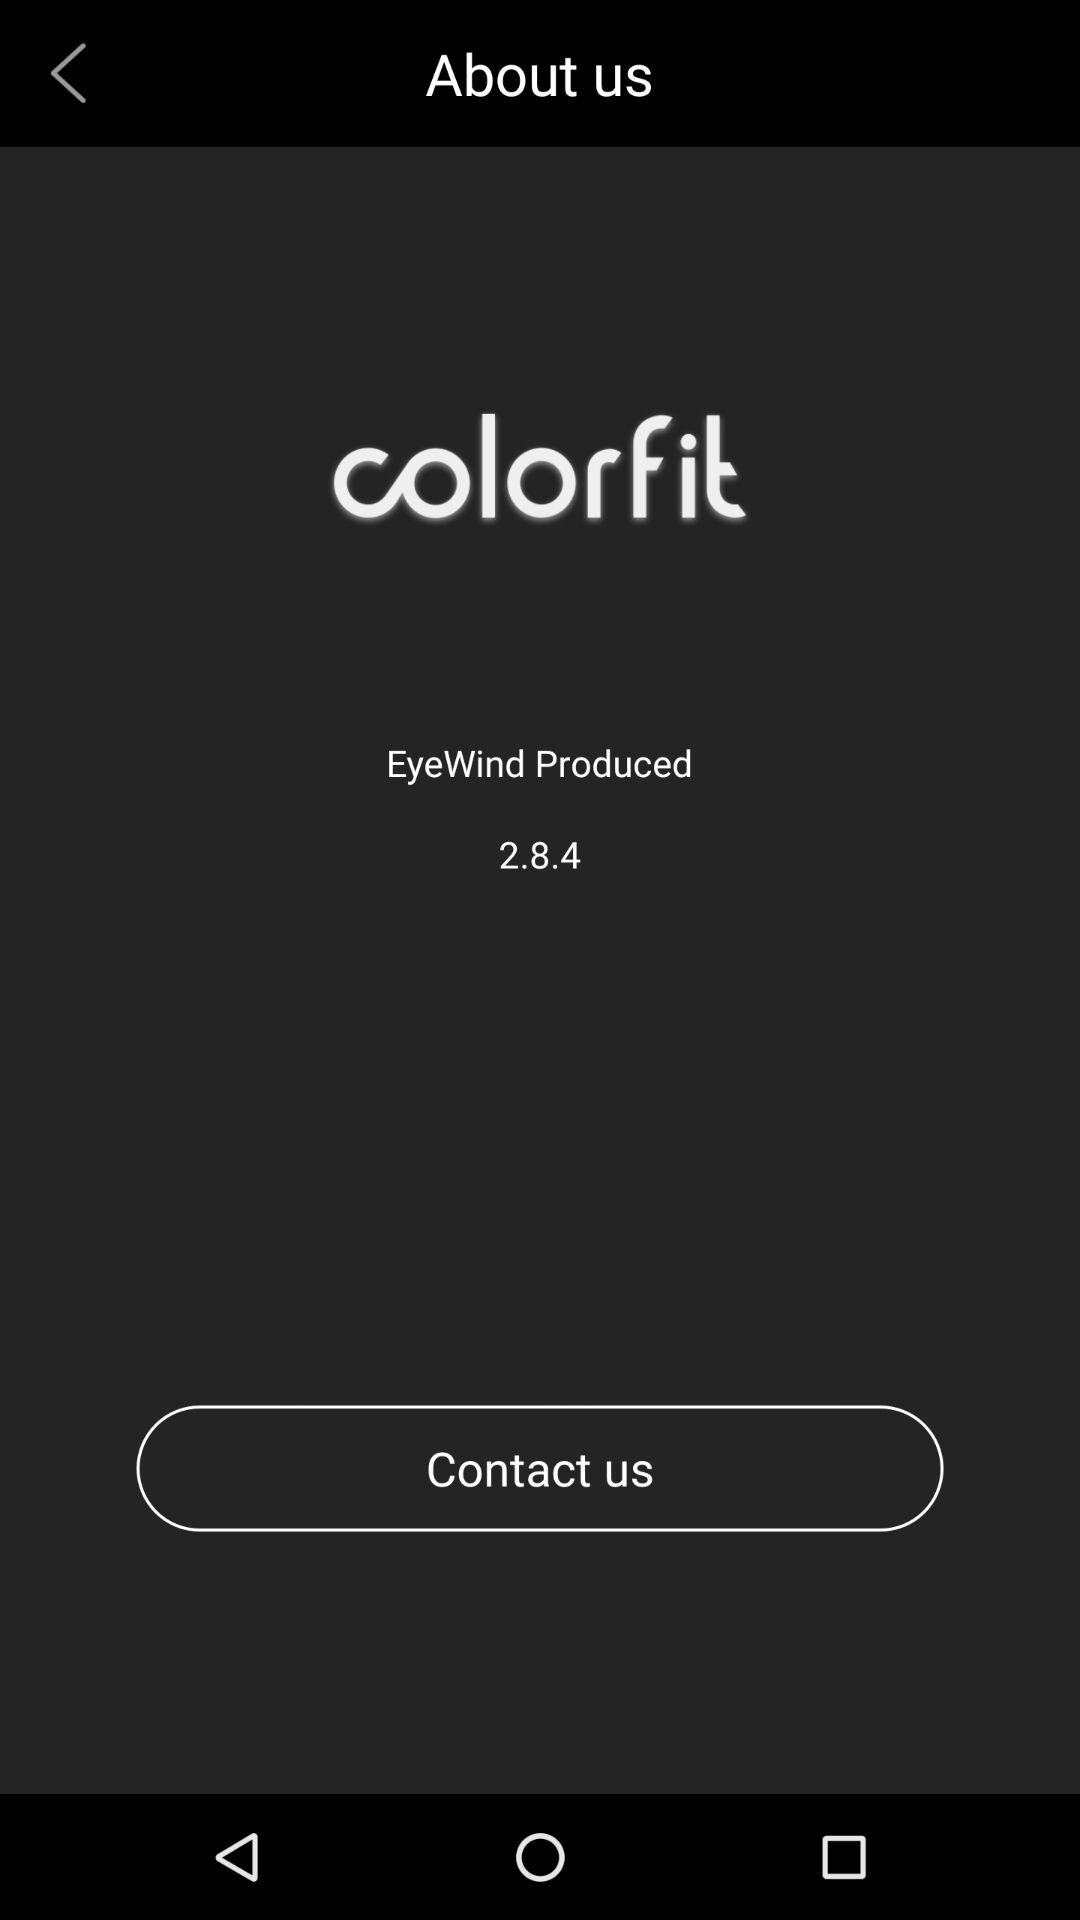What is the application name? The application name is "colorfit". 